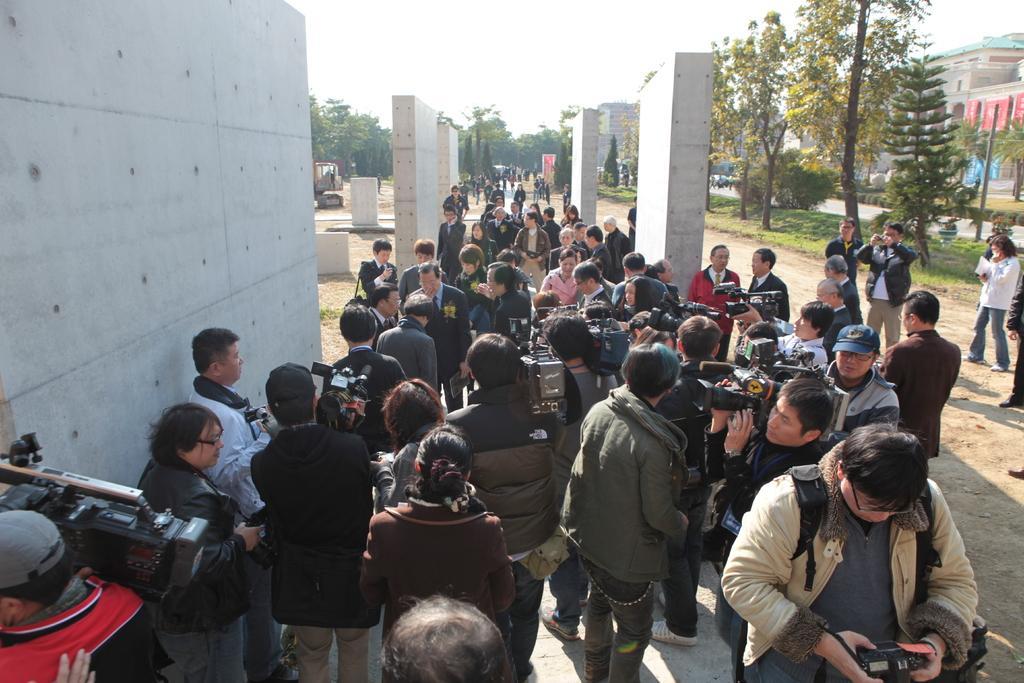Can you describe this image briefly? In this image there is a crowd. Few people are holding video cameras. Some are wearing caps. Also there are walls. And there are many trees. In the background there is sky. 